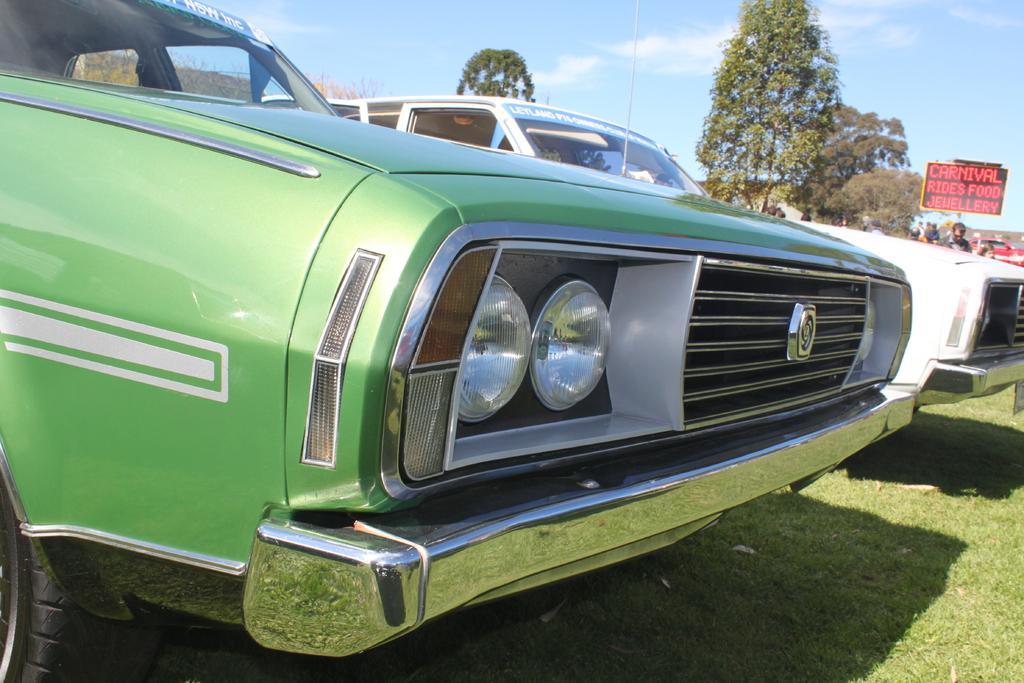Can you describe this image briefly? In the image there are two cars parked on the grass and around the cars there are many trees and beside the trees some people are standing and there is a board in between them and it is written as carnival on that board. 